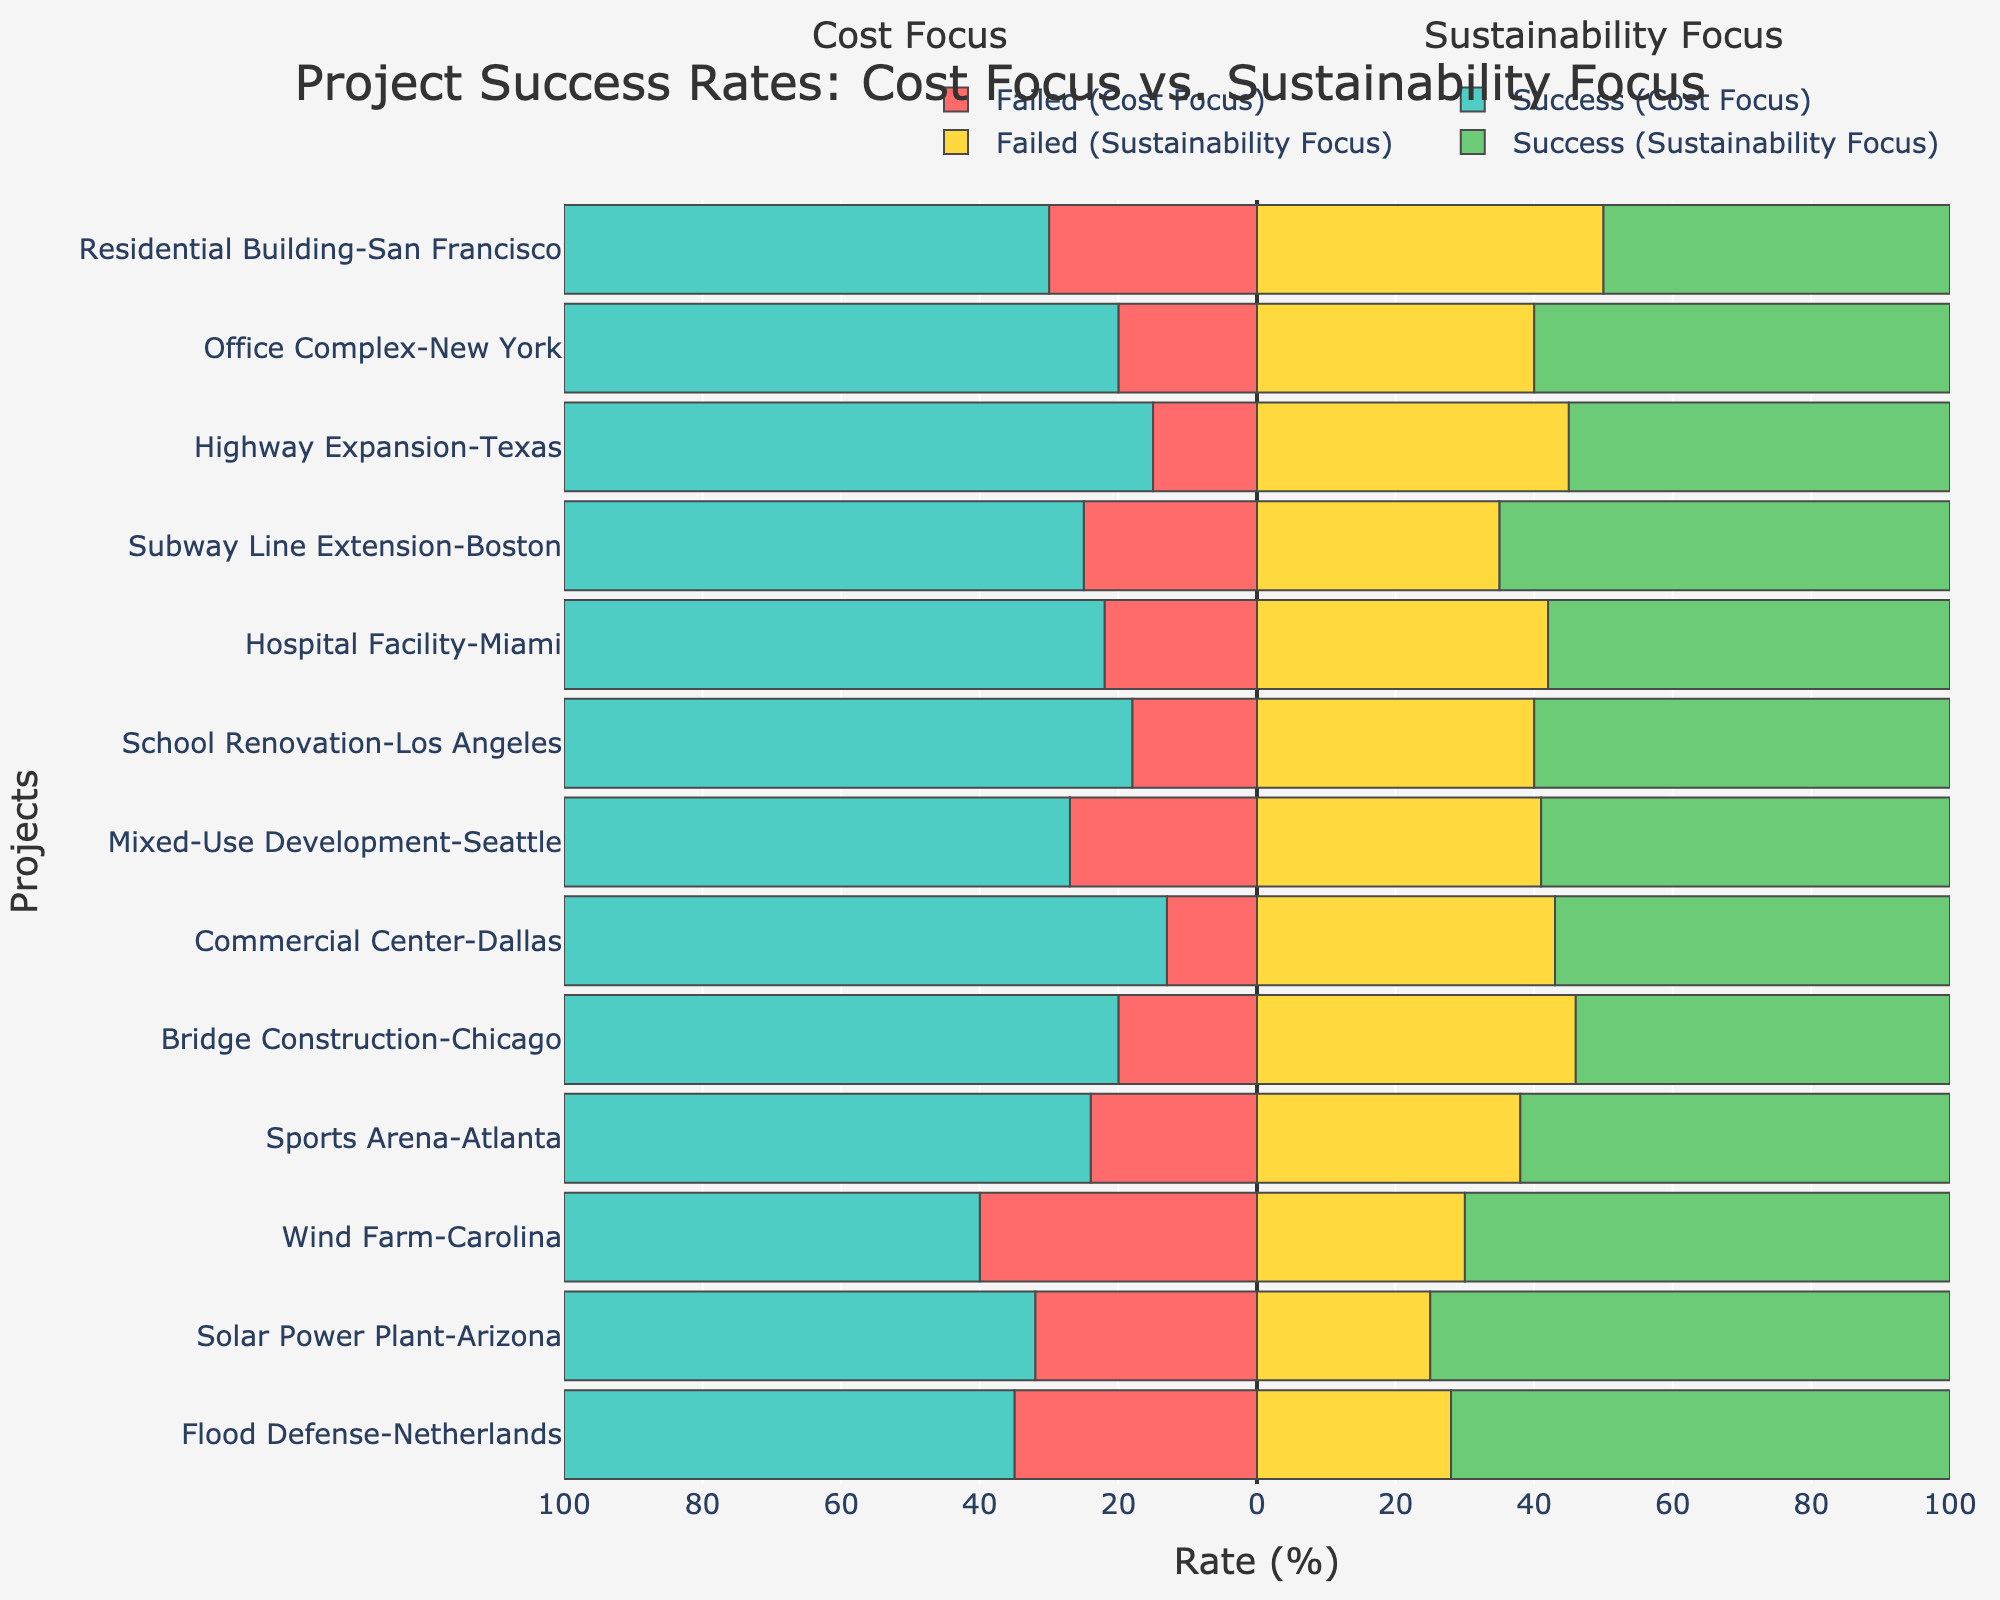What's the success rate for the highway expansion project with a cost focus? Locate the "Highway Expansion-Texas" project and refer to the green (right side, cost focus) bar length. "Success Rate (Cost Focus)" is given as 85%.
Answer: 85% Which project has the highest success rate under sustainability focus? Compare the green (left side, sustainability focus) bars' lengths and identify the longest one. The "Solar Power Plant-Arizona" and "Flood Defense-Netherlands" have the highest rates at 75% and 72%, respectively. The Solar Power Plant-Arizona is the highest.
Answer: Solar Power Plant-Arizona What's the difference in failed rates between cost and sustainability focus for the bridge construction project? Find "Bridge Construction-Chicago" and compare the red (cost focus) and yellow (sustainability focus) bar lengths for failed rates. The "Failed Rate (Cost Focus)" is 20%, and the "Failed Rate (Sustainability Focus)" is 46%. Calculate the difference: \(46% - 20% = 26%\).
Answer: 26% Which project shows a higher success rate for sustainability focus than cost focus? Compare green (right side, cost focus) and green (left side, sustainability focus) bars for all projects. Only "Wind Farm-Carolina," "Solar Power Plant-Arizona," and "Flood Defense-Netherlands" show higher rates in sustainability.
Answer: Wind Farm-Carolina, Solar Power Plant-Arizona, Flood Defense-Netherlands How many projects have a success rate of 65% or more under cost focus? Check the lengths of green bars (right side, cost focus) across all projects to see which ones meet or exceed 65%. Count these projects: Residential Building-San Francisco, Office Complex-New York, Highway Expansion-Texas, Subway Line Extension-Boston, Hospital Facility-Miami, School Renovation-Los Angeles, Mixed-Use Development-Seattle, Commercial Center-Dallas, Bridge Construction-Chicago, Sports Arena-Atlanta.
Answer: 10 Are there more projects with a higher success rate for cost focus or sustainability focus? Count the number of projects with greater green bar lengths (success rates) in cost focus and sustainability focus. Cost focus has more: 10 vs. 3 as identified earlier.
Answer: Cost Focus What’s the average success rate under sustainability focus for all projects? Add the sustainability success rates: \(50 + 60 + 55 + 65 + 58 + 60 + 59 + 57 + 54 + 62 + 70 + 75 + 72\) and divide by 13: \(797 / 13 = 61.31\).
Answer: 61.31% 